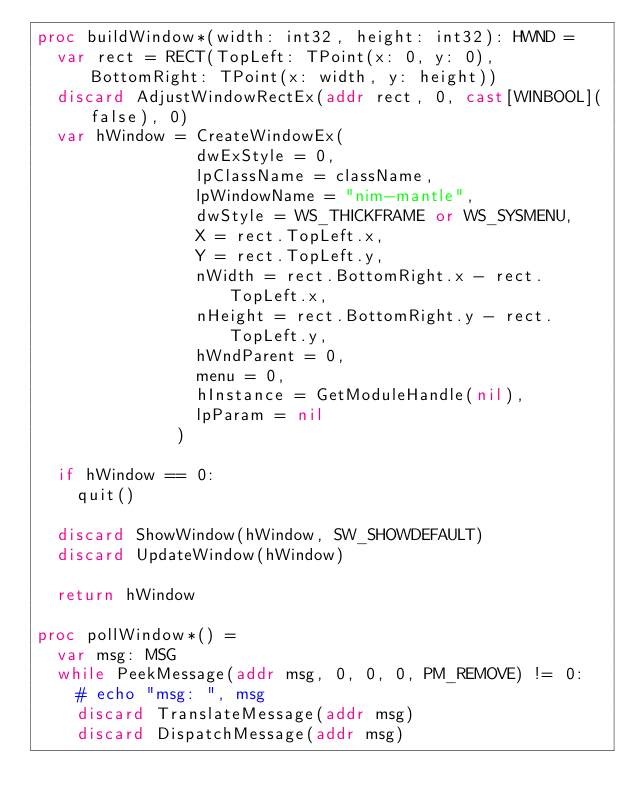Convert code to text. <code><loc_0><loc_0><loc_500><loc_500><_Nim_>proc buildWindow*(width: int32, height: int32): HWND =
  var rect = RECT(TopLeft: TPoint(x: 0, y: 0), BottomRight: TPoint(x: width, y: height))
  discard AdjustWindowRectEx(addr rect, 0, cast[WINBOOL](false), 0)
  var hWindow = CreateWindowEx(
                dwExStyle = 0,
                lpClassName = className,
                lpWindowName = "nim-mantle",
                dwStyle = WS_THICKFRAME or WS_SYSMENU,
                X = rect.TopLeft.x,
                Y = rect.TopLeft.y,
                nWidth = rect.BottomRight.x - rect.TopLeft.x,
                nHeight = rect.BottomRight.y - rect.TopLeft.y,
                hWndParent = 0,
                menu = 0,
                hInstance = GetModuleHandle(nil),
                lpParam = nil
              )

  if hWindow == 0:
    quit()

  discard ShowWindow(hWindow, SW_SHOWDEFAULT)
  discard UpdateWindow(hWindow)
  
  return hWindow

proc pollWindow*() =
  var msg: MSG
  while PeekMessage(addr msg, 0, 0, 0, PM_REMOVE) != 0:
    # echo "msg: ", msg
    discard TranslateMessage(addr msg)
    discard DispatchMessage(addr msg)
</code> 